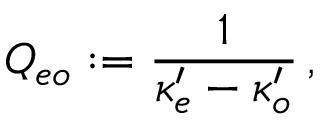Convert formula to latex. <formula><loc_0><loc_0><loc_500><loc_500>Q _ { e o } \colon = { \frac { 1 } { \kappa _ { e } ^ { \prime } - \kappa _ { o } ^ { \prime } } } \, ,</formula> 